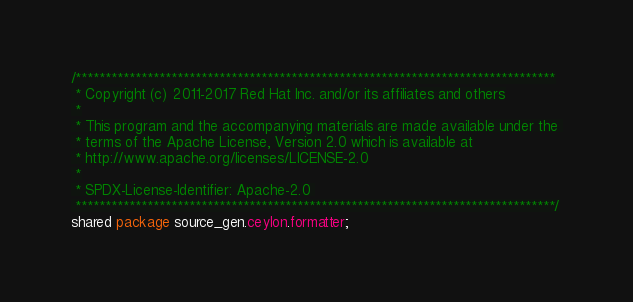<code> <loc_0><loc_0><loc_500><loc_500><_Ceylon_>/********************************************************************************
 * Copyright (c) 2011-2017 Red Hat Inc. and/or its affiliates and others
 *
 * This program and the accompanying materials are made available under the 
 * terms of the Apache License, Version 2.0 which is available at
 * http://www.apache.org/licenses/LICENSE-2.0
 *
 * SPDX-License-Identifier: Apache-2.0 
 ********************************************************************************/
shared package source_gen.ceylon.formatter;
</code> 